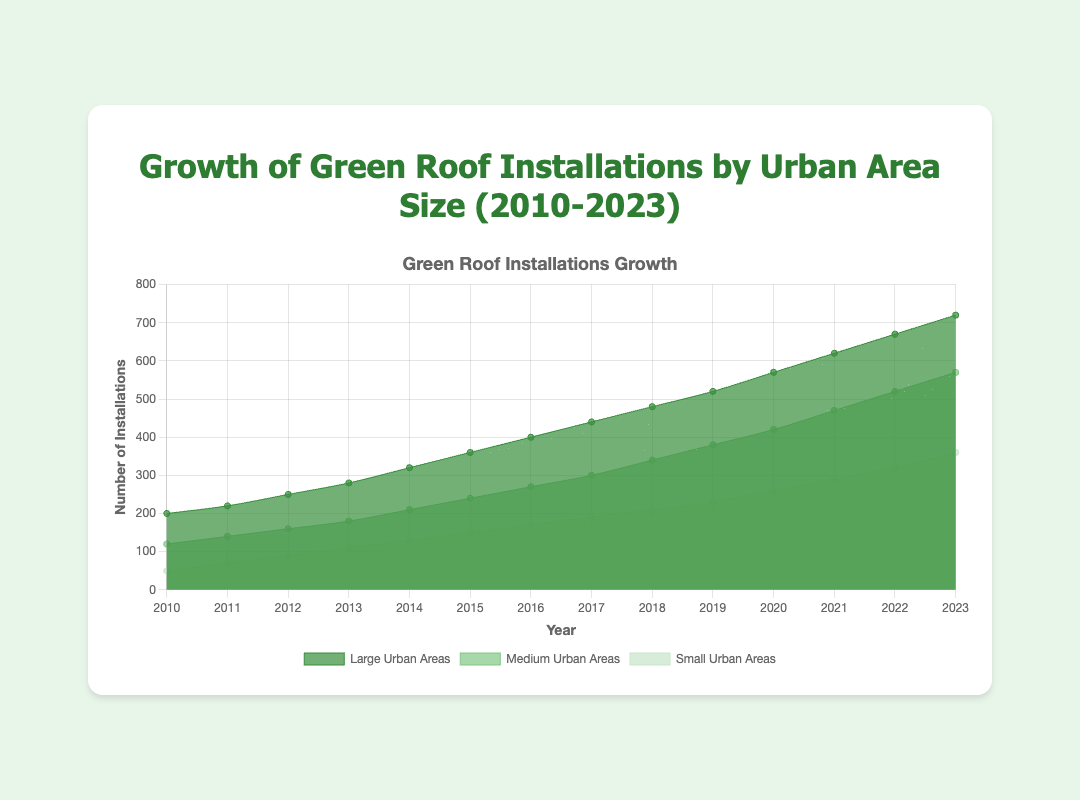What is the title of the figure? The title of the figure is prominently displayed at the top. It states "Growth of Green Roof Installations by Urban Area Size (2010-2023)"
Answer: Growth of Green Roof Installations by Urban Area Size (2010-2023) Which urban area size had the highest number of installations in 2023? By looking at the year 2023 on the x-axis and comparing the values for each urban area, the largest urban areas had the highest number of installations. These are visually the largest area plot in the chart.
Answer: Large Urban Areas How many installations were there in medium urban areas in 2017? Locate the year 2017 on the x-axis and find the corresponding value for the medium urban areas, which is given by the data for that year.
Answer: 300 By how much did the number of installations in small urban areas increase from 2010 to 2013? Find the values for small urban areas in 2010 and 2013 and calculate the difference: 110 - 50 = 60.
Answer: 60 Which year showed the first instance where installations in medium urban areas surpassed 400? Locate the segment of the chart where installations in medium urban areas first exceed 400. Based on the y-axis and the data trend, it is in the year 2020.
Answer: 2020 Compare the growth trend of green roof installations in large urban areas with small urban areas. What do you observe? Observing the overall trend lines, installations in large urban areas start higher and have a steeper increase over the years compared to installations in small urban areas, which start lower and increase more steadily.
Answer: Large urban areas have a steeper growth Which urban area size had the largest absolute increase in installations from 2011 to 2012? Calculate the difference in installations for each urban area size between 2011 and 2012 and determine which has the largest difference: Large (250 - 220 = 30), Medium (160 - 140 = 20), Small (90 - 70 = 20); the large urban areas have the largest increase.
Answer: Large Urban Areas What is the average number of installations in medium urban areas over the observed period (2010-2023)? Sum all the values for medium urban areas and divide by the number of years: (120+140+160+180+210+240+270+300+340+380+420+470+520+570)/14 = 315.
Answer: 315 Is the rate of increase for green roof installations higher in large urban areas or small urban areas between 2018 and 2021? Calculate the rate of increase for both large and small urban areas from 2018 to 2021: Large Urban Areas (620-480)/3 = 46.67, Small Urban Areas (290-210)/3 = 26.67; compare the values.
Answer: Large Urban Areas What is the total number of green roof installations across all urban areas in 2015? Sum installations for all three urban area sizes in 2015: 150 + 240 + 360 = 750.
Answer: 750 